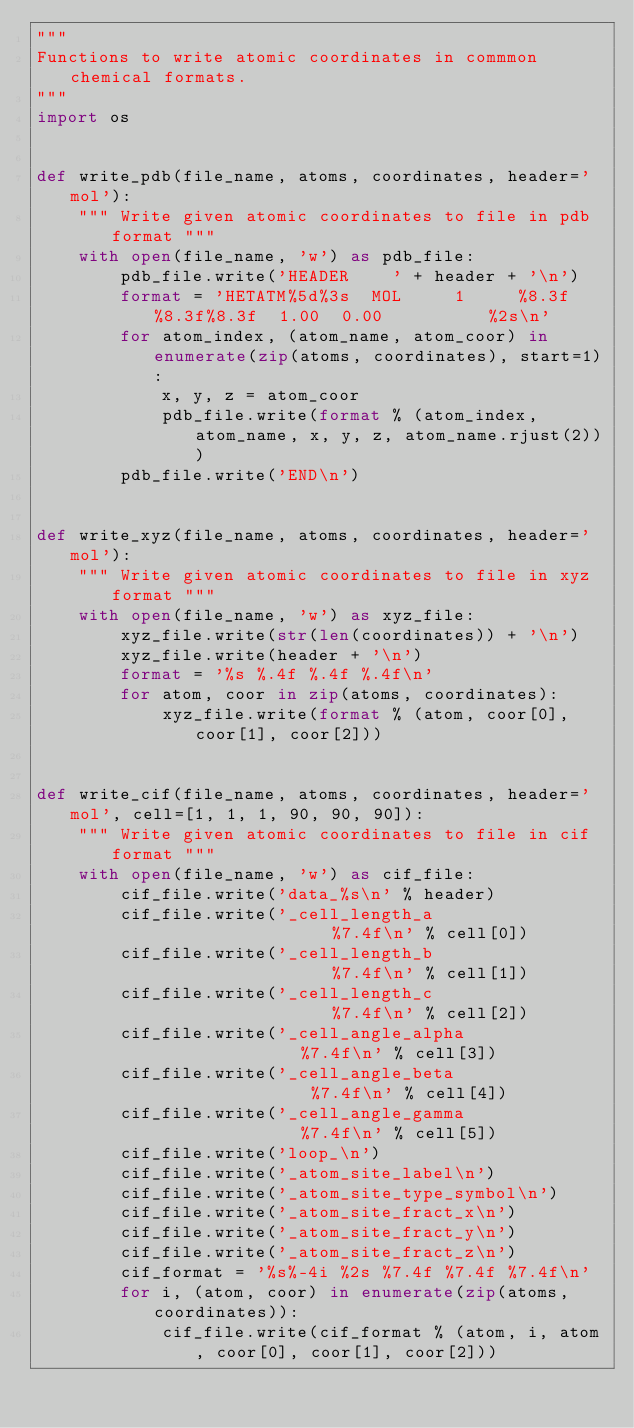Convert code to text. <code><loc_0><loc_0><loc_500><loc_500><_Python_>"""
Functions to write atomic coordinates in commmon chemical formats.
"""
import os


def write_pdb(file_name, atoms, coordinates, header='mol'):
    """ Write given atomic coordinates to file in pdb format """
    with open(file_name, 'w') as pdb_file:
        pdb_file.write('HEADER    ' + header + '\n')
        format = 'HETATM%5d%3s  MOL     1     %8.3f%8.3f%8.3f  1.00  0.00          %2s\n'
        for atom_index, (atom_name, atom_coor) in enumerate(zip(atoms, coordinates), start=1):
            x, y, z = atom_coor
            pdb_file.write(format % (atom_index, atom_name, x, y, z, atom_name.rjust(2)))
        pdb_file.write('END\n')


def write_xyz(file_name, atoms, coordinates, header='mol'):
    """ Write given atomic coordinates to file in xyz format """
    with open(file_name, 'w') as xyz_file:
        xyz_file.write(str(len(coordinates)) + '\n')
        xyz_file.write(header + '\n')
        format = '%s %.4f %.4f %.4f\n'
        for atom, coor in zip(atoms, coordinates):
            xyz_file.write(format % (atom, coor[0], coor[1], coor[2]))


def write_cif(file_name, atoms, coordinates, header='mol', cell=[1, 1, 1, 90, 90, 90]):
    """ Write given atomic coordinates to file in cif format """
    with open(file_name, 'w') as cif_file:
        cif_file.write('data_%s\n' % header)
        cif_file.write('_cell_length_a                  %7.4f\n' % cell[0])
        cif_file.write('_cell_length_b                  %7.4f\n' % cell[1])
        cif_file.write('_cell_length_c                  %7.4f\n' % cell[2])
        cif_file.write('_cell_angle_alpha               %7.4f\n' % cell[3])
        cif_file.write('_cell_angle_beta                %7.4f\n' % cell[4])
        cif_file.write('_cell_angle_gamma               %7.4f\n' % cell[5])
        cif_file.write('loop_\n')
        cif_file.write('_atom_site_label\n')
        cif_file.write('_atom_site_type_symbol\n')
        cif_file.write('_atom_site_fract_x\n')
        cif_file.write('_atom_site_fract_y\n')
        cif_file.write('_atom_site_fract_z\n')
        cif_format = '%s%-4i %2s %7.4f %7.4f %7.4f\n'
        for i, (atom, coor) in enumerate(zip(atoms, coordinates)):
            cif_file.write(cif_format % (atom, i, atom, coor[0], coor[1], coor[2]))
</code> 